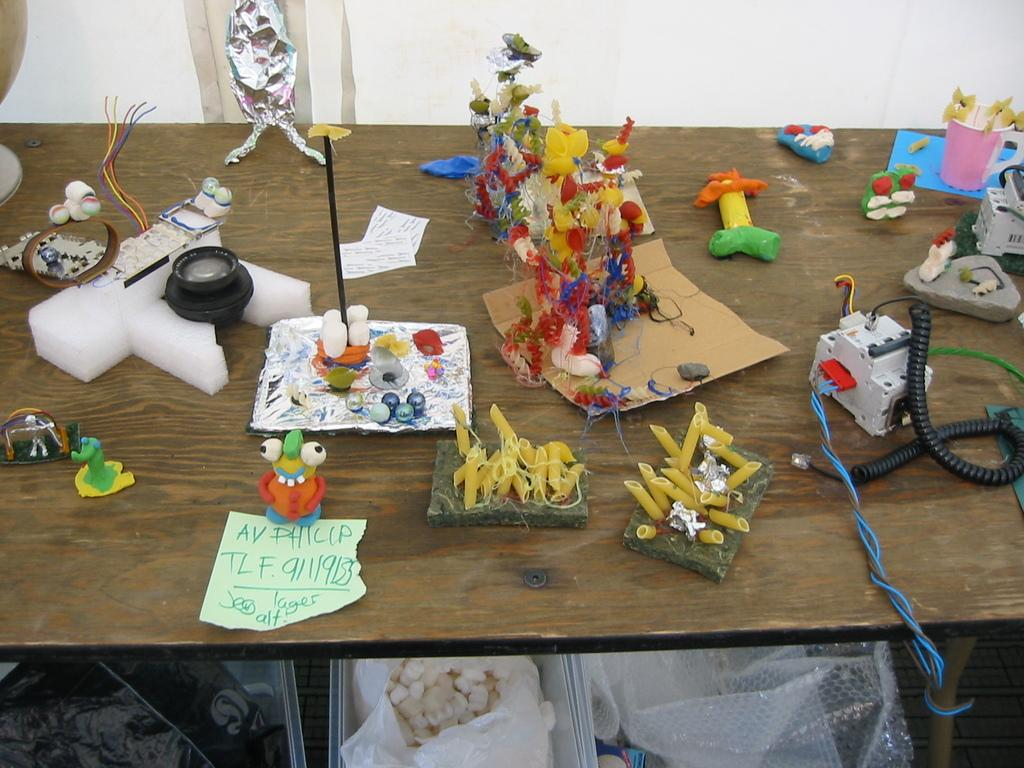What is the main piece of furniture in the image? There is a table. What electronic device is on the table? A camera is present on the table. What type of objects can be seen on the table besides the camera? There are toys, a spring, and a motor on the table. What is located below the table? There is a plastic cover and cotton below the table. What type of knee support is visible in the image? There is no knee support present in the image. What type of trousers is the person wearing in the image? There is no person or trousers visible in the image. 